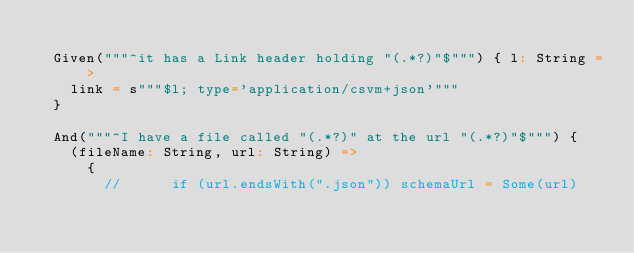<code> <loc_0><loc_0><loc_500><loc_500><_Scala_>
  Given("""^it has a Link header holding "(.*?)"$""") { l: String =>
    link = s"""$l; type='application/csvm+json'"""
  }

  And("""^I have a file called "(.*?)" at the url "(.*?)"$""") {
    (fileName: String, url: String) =>
      {
        //      if (url.endsWith(".json")) schemaUrl = Some(url)</code> 